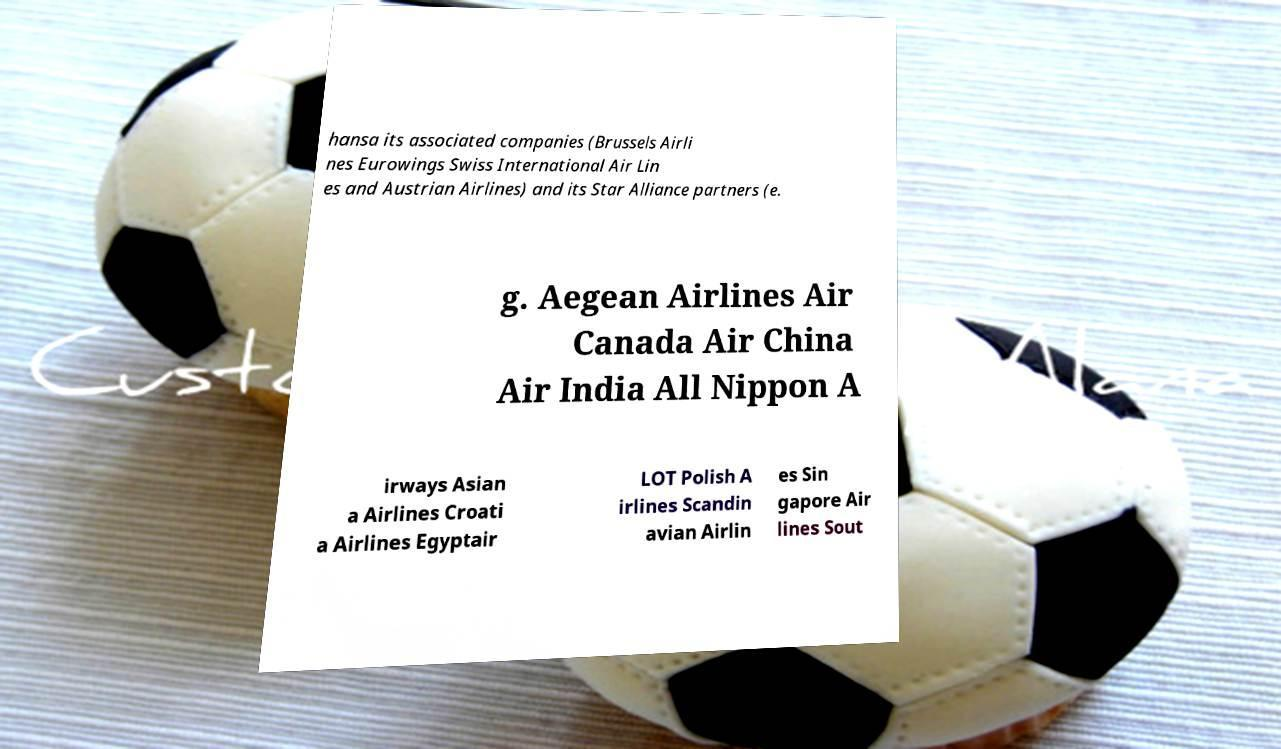Please read and relay the text visible in this image. What does it say? hansa its associated companies (Brussels Airli nes Eurowings Swiss International Air Lin es and Austrian Airlines) and its Star Alliance partners (e. g. Aegean Airlines Air Canada Air China Air India All Nippon A irways Asian a Airlines Croati a Airlines Egyptair LOT Polish A irlines Scandin avian Airlin es Sin gapore Air lines Sout 